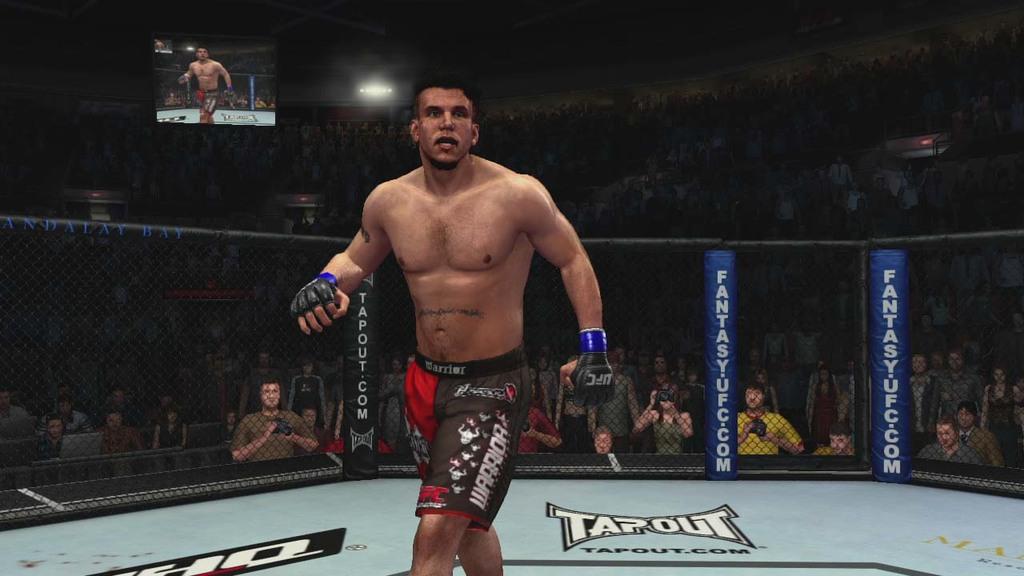What is the website affiliated with this video game?
Ensure brevity in your answer.  Tapout.com. What does the wrestler's shorts say?
Your response must be concise. Warrior. 